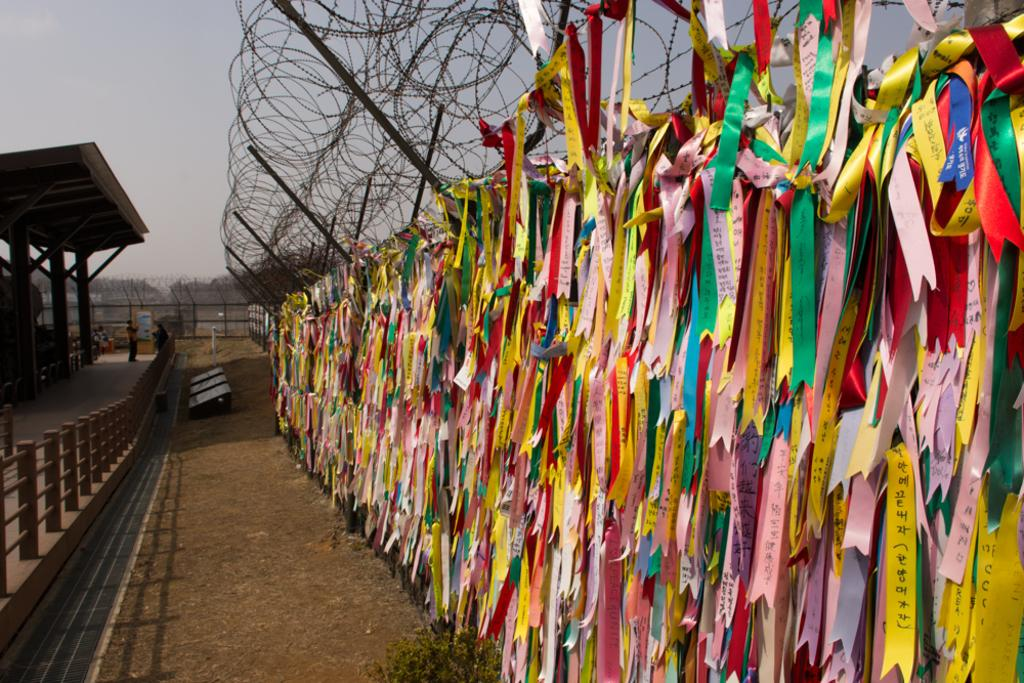What type of decorative items can be seen in the image? There are multi-color ribbons in the image. How are the ribbons arranged or positioned? The ribbons are hanged on a railing. What can be seen in the background of the image? There is a shed and dried trees in the background of the image. What is the color of the sky in the image? The sky is gray in color. What letter is being used to measure the length of the ribbons in the image? There is no letter or measuring tool present in the image; the ribbons are simply hanging on a railing. 